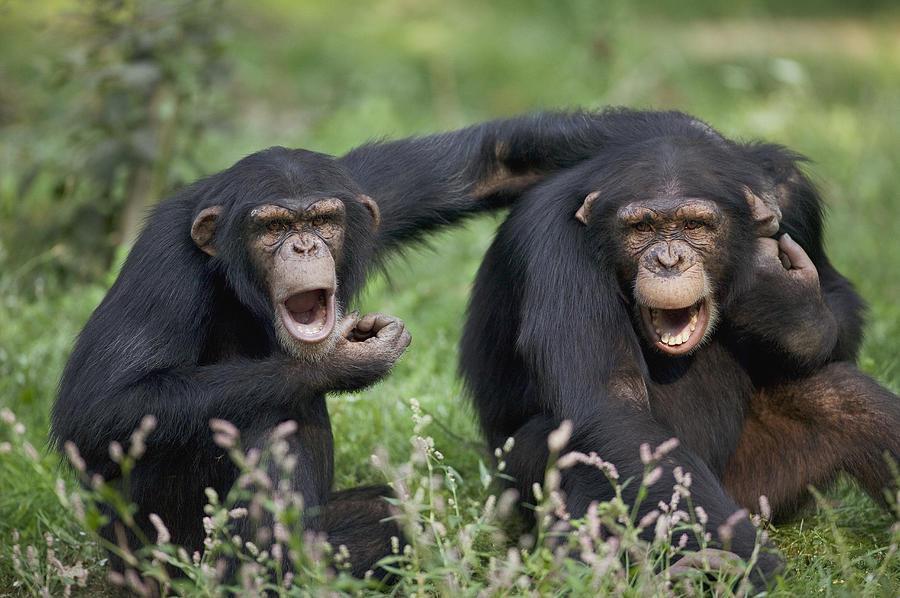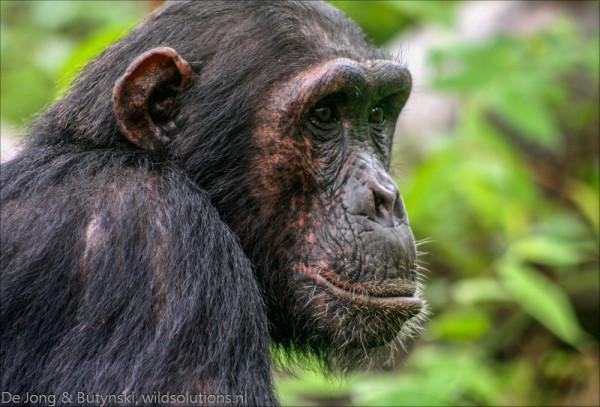The first image is the image on the left, the second image is the image on the right. Given the left and right images, does the statement "there are chimps with open wide moths displayed" hold true? Answer yes or no. Yes. The first image is the image on the left, the second image is the image on the right. Examine the images to the left and right. Is the description "An image shows a horizontal row of exactly five chimps." accurate? Answer yes or no. No. 